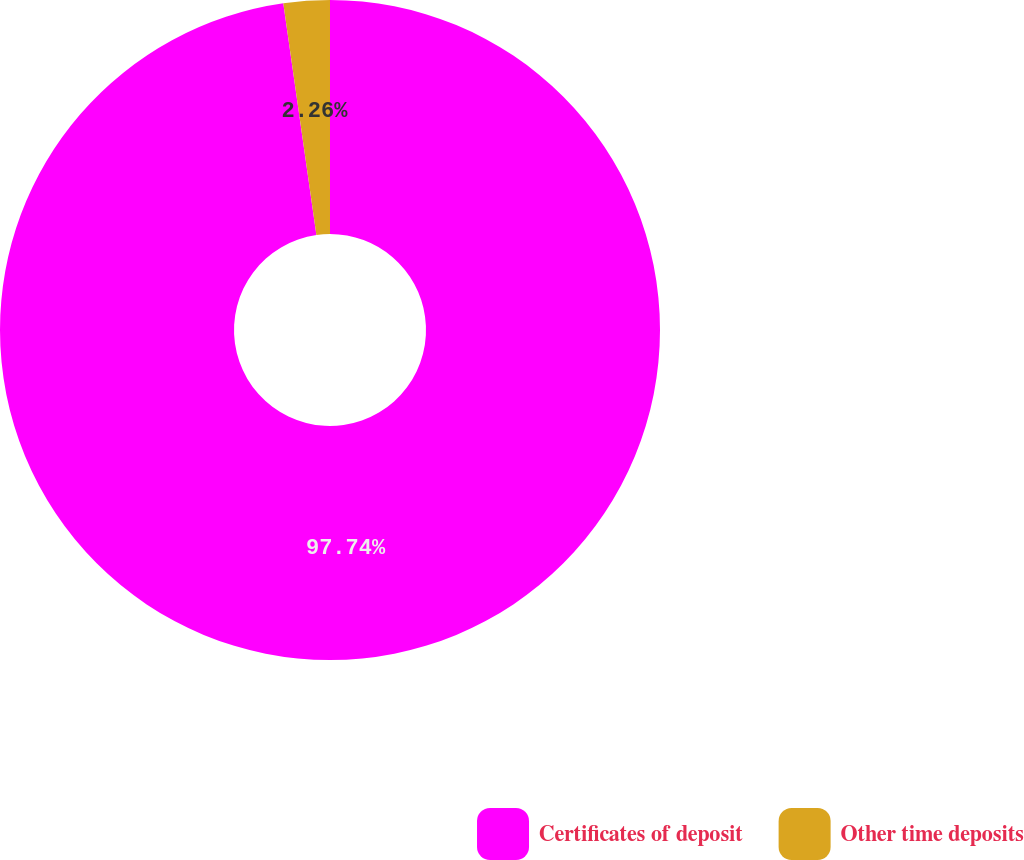Convert chart to OTSL. <chart><loc_0><loc_0><loc_500><loc_500><pie_chart><fcel>Certificates of deposit<fcel>Other time deposits<nl><fcel>97.74%<fcel>2.26%<nl></chart> 